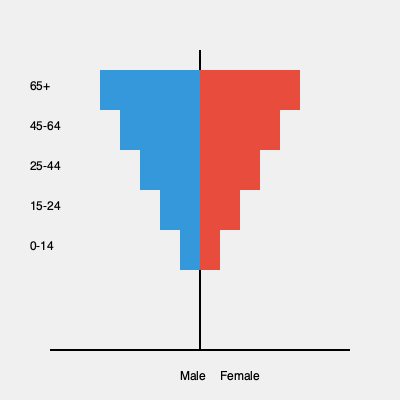As a sports blogger aiming to expand your reader base, you're analyzing a population pyramid to identify potential target demographics. Based on the chart, which age group would likely be the most promising for promoting content about professional sports careers and athlete development? To answer this question, we need to analyze the population pyramid and consider the characteristics of different age groups in relation to professional sports careers and athlete development:

1. The pyramid shows age groups from 0-14 at the bottom to 65+ at the top.
2. The width of each bar represents the population size for that age group.
3. We're looking for an age group that would be most interested in professional sports careers and athlete development.

Let's examine each age group:

1. 0-14: Too young for professional sports careers, but may be interested in early athlete development.
2. 15-24: This group is likely to be actively pursuing sports careers or in the early stages of professional development.
3. 25-44: This is the largest group, representing prime years for professional athletes and those interested in sports careers.
4. 45-64: While some may still be involved in sports, this group is less likely to be actively pursuing new sports careers.
5. 65+: Least likely to be interested in pursuing professional sports careers.

Considering the focus on professional sports careers and athlete development, the 25-44 age group would be the most promising target demographic for several reasons:

1. It's the largest population group, offering the biggest potential audience.
2. This age range encompasses both young professionals starting their careers and established athletes at their peak.
3. People in this age group are likely to be interested in career development and performance improvement topics.
4. They may also be coaches, trainers, or parents of young athletes, making them interested in athlete development content.

By targeting this group, you can create content that appeals to a wide range of sports professionals, aspiring athletes, and those involved in athlete development, potentially maximizing your reader base expansion.
Answer: 25-44 age group 